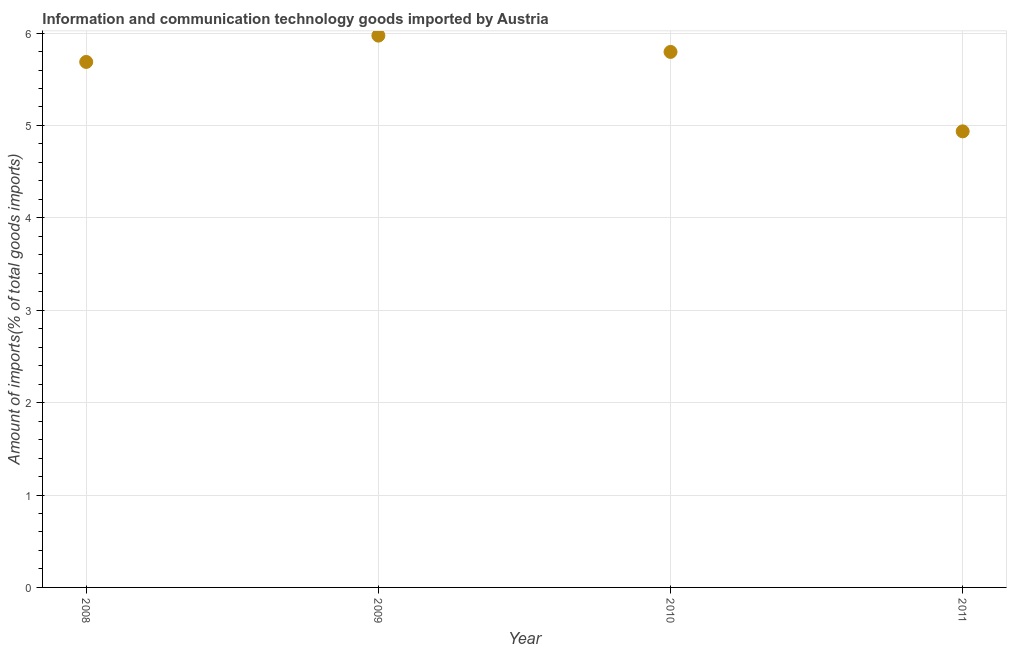What is the amount of ict goods imports in 2008?
Offer a terse response. 5.69. Across all years, what is the maximum amount of ict goods imports?
Your response must be concise. 5.97. Across all years, what is the minimum amount of ict goods imports?
Offer a terse response. 4.94. In which year was the amount of ict goods imports maximum?
Your answer should be compact. 2009. What is the sum of the amount of ict goods imports?
Give a very brief answer. 22.39. What is the difference between the amount of ict goods imports in 2009 and 2011?
Your answer should be compact. 1.04. What is the average amount of ict goods imports per year?
Provide a succinct answer. 5.6. What is the median amount of ict goods imports?
Provide a succinct answer. 5.74. In how many years, is the amount of ict goods imports greater than 3.6 %?
Your response must be concise. 4. What is the ratio of the amount of ict goods imports in 2010 to that in 2011?
Provide a succinct answer. 1.17. Is the amount of ict goods imports in 2009 less than that in 2010?
Provide a short and direct response. No. What is the difference between the highest and the second highest amount of ict goods imports?
Make the answer very short. 0.18. Is the sum of the amount of ict goods imports in 2010 and 2011 greater than the maximum amount of ict goods imports across all years?
Keep it short and to the point. Yes. What is the difference between the highest and the lowest amount of ict goods imports?
Give a very brief answer. 1.04. In how many years, is the amount of ict goods imports greater than the average amount of ict goods imports taken over all years?
Ensure brevity in your answer.  3. How many dotlines are there?
Your answer should be very brief. 1. How many years are there in the graph?
Keep it short and to the point. 4. What is the difference between two consecutive major ticks on the Y-axis?
Your answer should be very brief. 1. Are the values on the major ticks of Y-axis written in scientific E-notation?
Provide a succinct answer. No. Does the graph contain grids?
Provide a succinct answer. Yes. What is the title of the graph?
Provide a short and direct response. Information and communication technology goods imported by Austria. What is the label or title of the X-axis?
Offer a terse response. Year. What is the label or title of the Y-axis?
Your answer should be compact. Amount of imports(% of total goods imports). What is the Amount of imports(% of total goods imports) in 2008?
Make the answer very short. 5.69. What is the Amount of imports(% of total goods imports) in 2009?
Make the answer very short. 5.97. What is the Amount of imports(% of total goods imports) in 2010?
Ensure brevity in your answer.  5.8. What is the Amount of imports(% of total goods imports) in 2011?
Your response must be concise. 4.94. What is the difference between the Amount of imports(% of total goods imports) in 2008 and 2009?
Make the answer very short. -0.28. What is the difference between the Amount of imports(% of total goods imports) in 2008 and 2010?
Your answer should be very brief. -0.11. What is the difference between the Amount of imports(% of total goods imports) in 2008 and 2011?
Make the answer very short. 0.75. What is the difference between the Amount of imports(% of total goods imports) in 2009 and 2010?
Your response must be concise. 0.18. What is the difference between the Amount of imports(% of total goods imports) in 2009 and 2011?
Make the answer very short. 1.04. What is the difference between the Amount of imports(% of total goods imports) in 2010 and 2011?
Ensure brevity in your answer.  0.86. What is the ratio of the Amount of imports(% of total goods imports) in 2008 to that in 2011?
Make the answer very short. 1.15. What is the ratio of the Amount of imports(% of total goods imports) in 2009 to that in 2011?
Keep it short and to the point. 1.21. What is the ratio of the Amount of imports(% of total goods imports) in 2010 to that in 2011?
Provide a succinct answer. 1.17. 